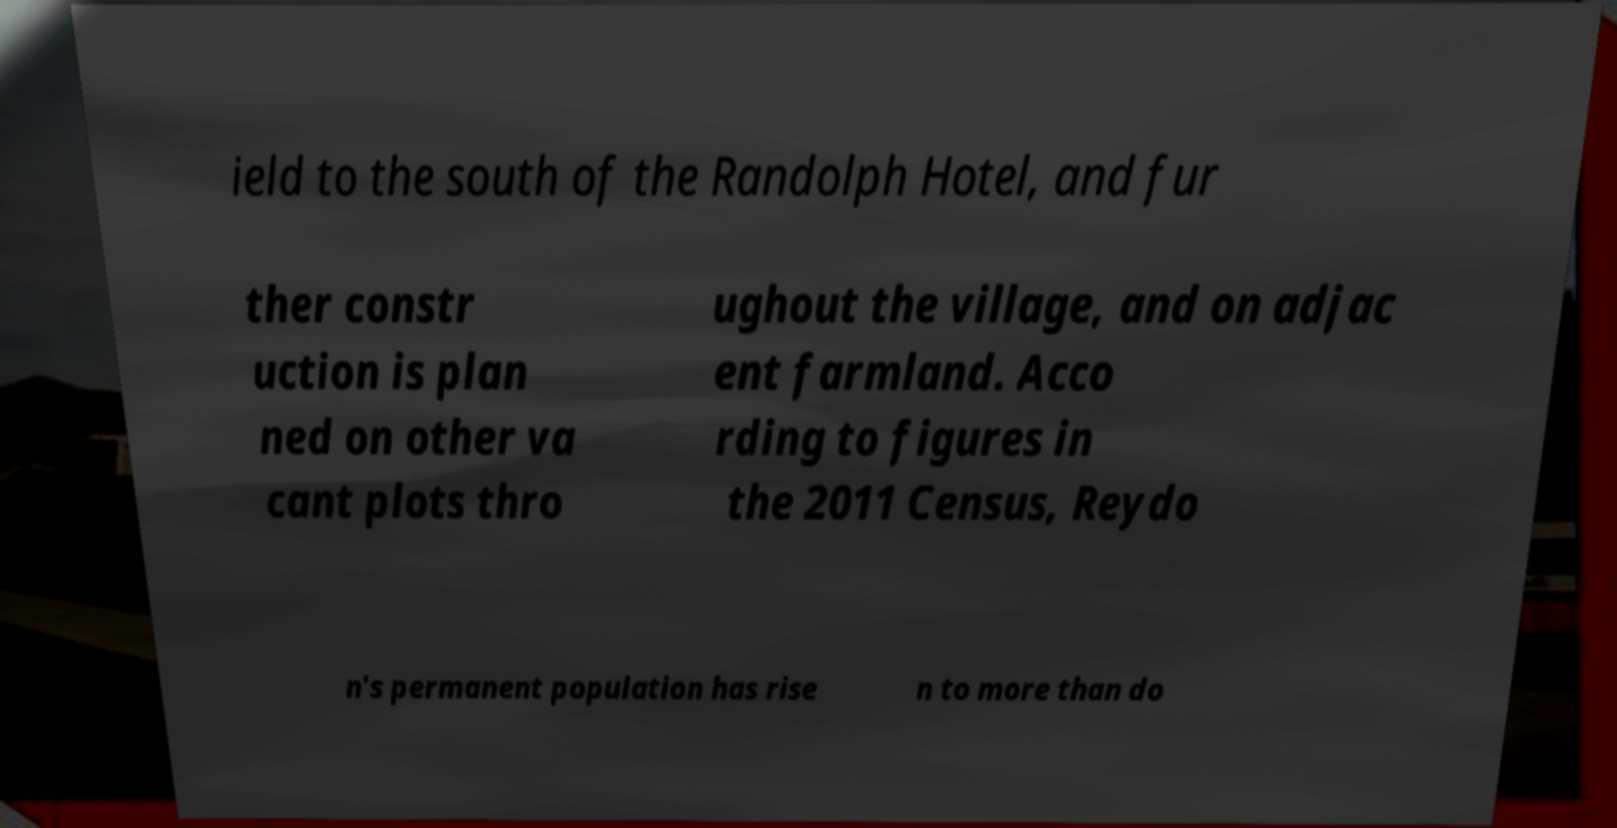Please read and relay the text visible in this image. What does it say? ield to the south of the Randolph Hotel, and fur ther constr uction is plan ned on other va cant plots thro ughout the village, and on adjac ent farmland. Acco rding to figures in the 2011 Census, Reydo n's permanent population has rise n to more than do 